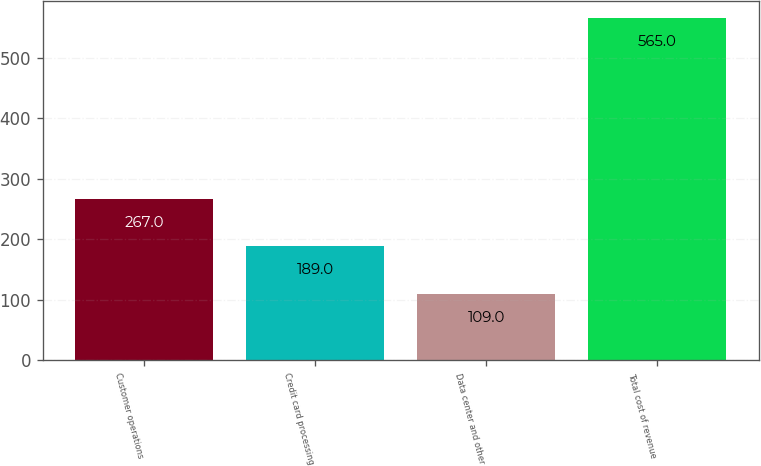Convert chart. <chart><loc_0><loc_0><loc_500><loc_500><bar_chart><fcel>Customer operations<fcel>Credit card processing<fcel>Data center and other<fcel>Total cost of revenue<nl><fcel>267<fcel>189<fcel>109<fcel>565<nl></chart> 